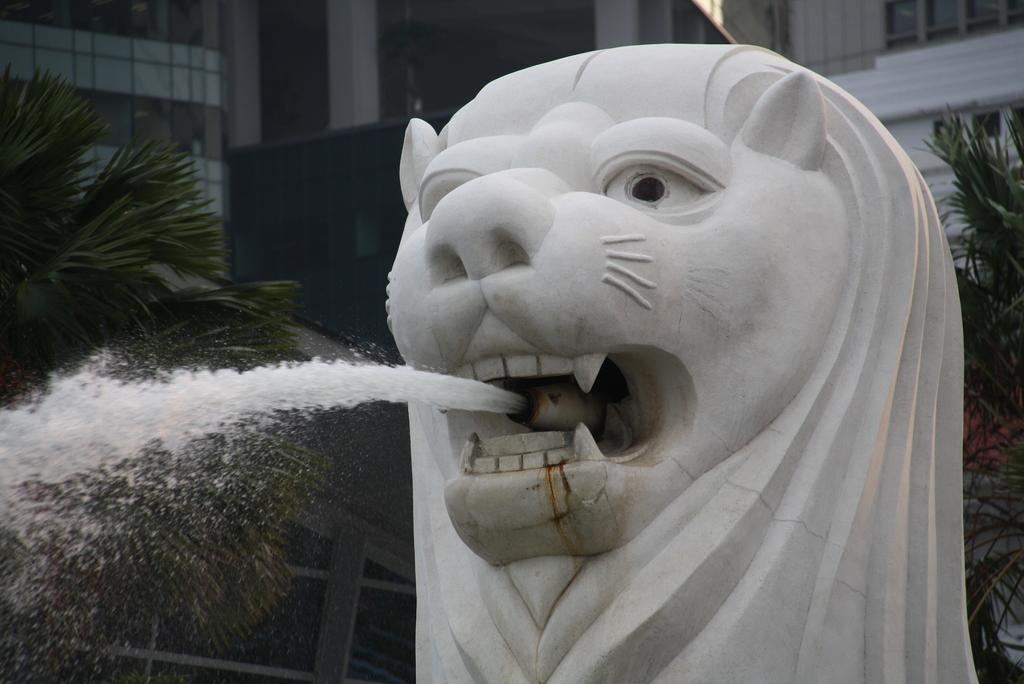What is the main subject in the middle of the image? There is a statue in the middle of the image. What is the statue doing in the image? Water is flowing from the mouth of the statue. What can be seen in the background of the image? There are trees, buildings, and a glass window in the background of the image. What decision did the statue make in the image? The statue is not capable of making decisions, as it is an inanimate object. 